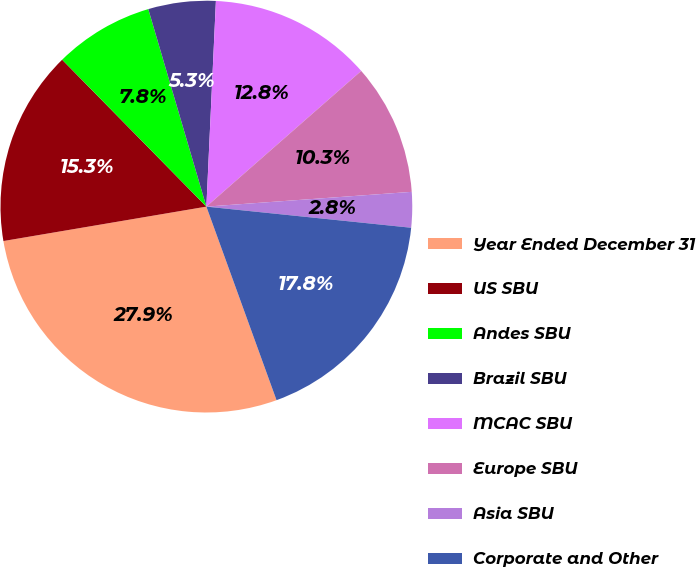Convert chart. <chart><loc_0><loc_0><loc_500><loc_500><pie_chart><fcel>Year Ended December 31<fcel>US SBU<fcel>Andes SBU<fcel>Brazil SBU<fcel>MCAC SBU<fcel>Europe SBU<fcel>Asia SBU<fcel>Corporate and Other<nl><fcel>27.86%<fcel>15.32%<fcel>7.8%<fcel>5.29%<fcel>12.81%<fcel>10.31%<fcel>2.78%<fcel>17.83%<nl></chart> 